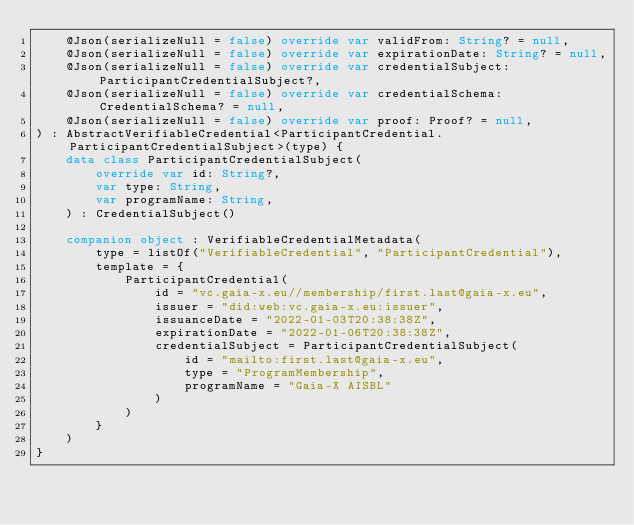<code> <loc_0><loc_0><loc_500><loc_500><_Kotlin_>    @Json(serializeNull = false) override var validFrom: String? = null,
    @Json(serializeNull = false) override var expirationDate: String? = null,
    @Json(serializeNull = false) override var credentialSubject: ParticipantCredentialSubject?,
    @Json(serializeNull = false) override var credentialSchema: CredentialSchema? = null,
    @Json(serializeNull = false) override var proof: Proof? = null,
) : AbstractVerifiableCredential<ParticipantCredential.ParticipantCredentialSubject>(type) {
    data class ParticipantCredentialSubject(
        override var id: String?,
        var type: String,
        var programName: String,
    ) : CredentialSubject()

    companion object : VerifiableCredentialMetadata(
        type = listOf("VerifiableCredential", "ParticipantCredential"),
        template = {
            ParticipantCredential(
                id = "vc.gaia-x.eu//membership/first.last@gaia-x.eu",
                issuer = "did:web:vc.gaia-x.eu:issuer",
                issuanceDate = "2022-01-03T20:38:38Z",
                expirationDate = "2022-01-06T20:38:38Z",
                credentialSubject = ParticipantCredentialSubject(
                    id = "mailto:first.last@gaia-x.eu",
                    type = "ProgramMembership",
                    programName = "Gaia-X AISBL"
                )
            )
        }
    )
}
</code> 